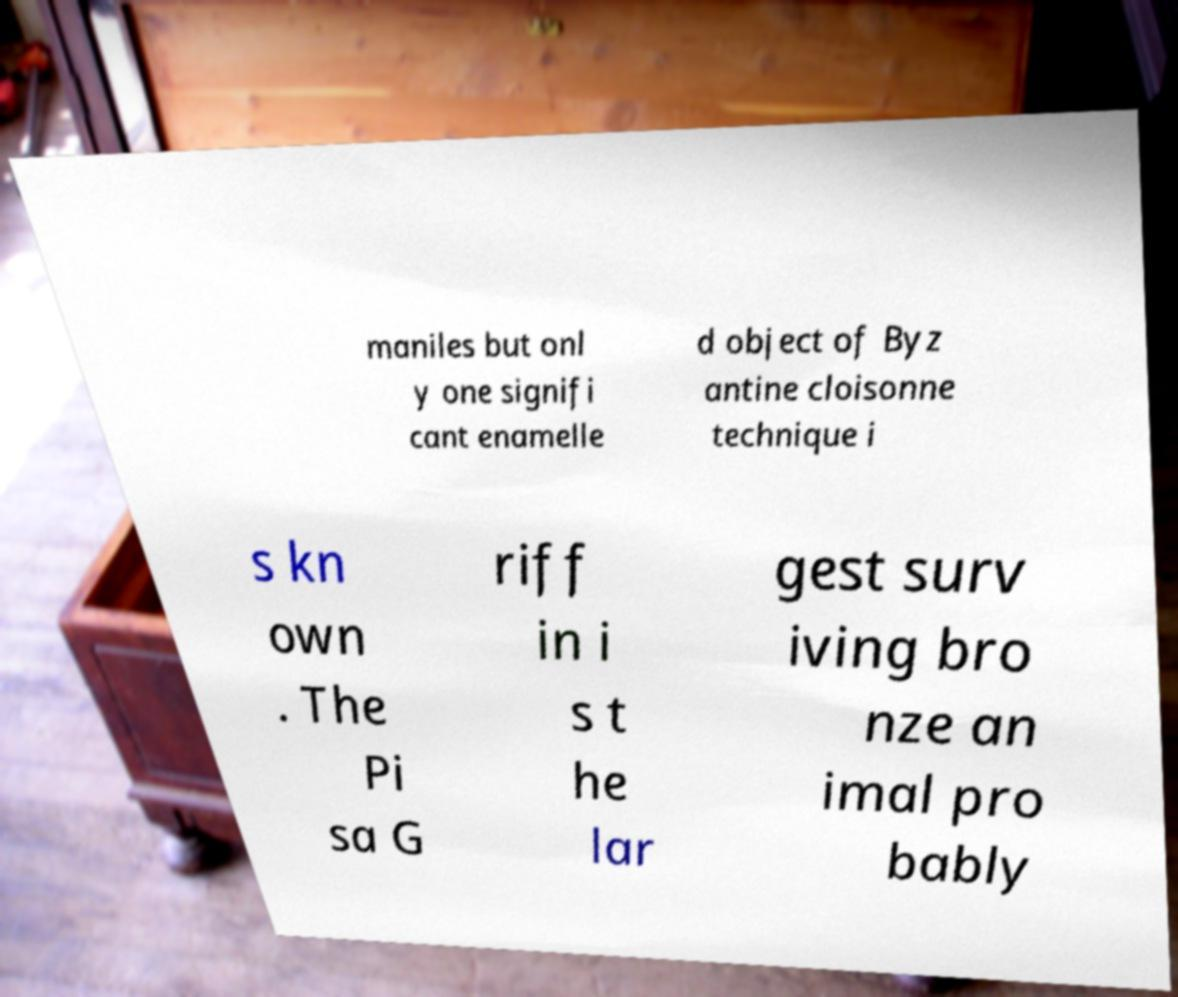There's text embedded in this image that I need extracted. Can you transcribe it verbatim? maniles but onl y one signifi cant enamelle d object of Byz antine cloisonne technique i s kn own . The Pi sa G riff in i s t he lar gest surv iving bro nze an imal pro bably 